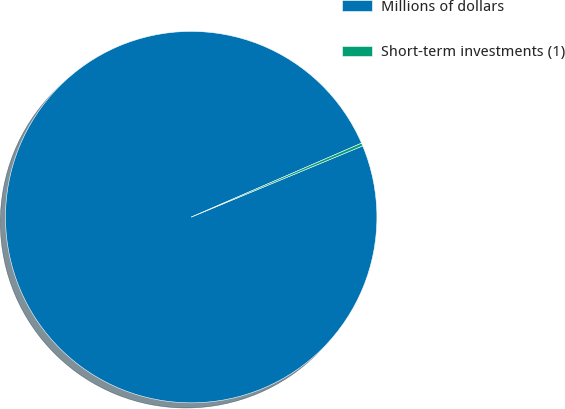Convert chart. <chart><loc_0><loc_0><loc_500><loc_500><pie_chart><fcel>Millions of dollars<fcel>Short-term investments (1)<nl><fcel>99.75%<fcel>0.25%<nl></chart> 